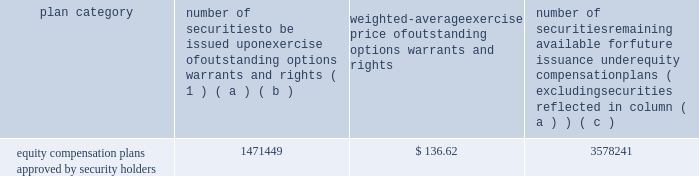Part a0iii item a010 .
Directors , executive officers and corporate governance for the information required by this item a010 with respect to our executive officers , see part a0i , item 1 .
Of this report .
For the other information required by this item a010 , see 201celection of directors , 201d 201cnominees for election to the board of directors , 201d 201ccorporate governance 201d and 201csection a016 ( a ) beneficial ownership reporting compliance , 201d in the proxy statement for our 2019 annual meeting , which information is incorporated herein by reference .
The proxy statement for our 2019 annual meeting will be filed within 120 a0days after the end of the fiscal year covered by this annual report on form 10-k .
Item a011 .
Executive compensation for the information required by this item a011 , see 201ccompensation discussion and analysis , 201d 201ccompensation committee report , 201d and 201cexecutive compensation 201d in the proxy statement for our 2019 annual meeting , which information is incorporated herein by reference .
Item a012 .
Security ownership of certain beneficial owners and management and related stockholder matters for the information required by this item a012 with respect to beneficial ownership of our common stock , see 201csecurity ownership of certain beneficial owners and management 201d in the proxy statement for our 2019 annual meeting , which information is incorporated herein by reference .
The table sets forth certain information as of december a031 , 2018 regarding our equity plans : plan category number of securities to be issued upon exercise of outstanding options , warrants and rights ( 1 ) weighted-average exercise price of outstanding options , warrants and rights number of securities remaining available for future issuance under equity compensation plans ( excluding securities reflected in column ( a ) ( b ) ( c ) equity compensation plans approved by security holders 1471449 $ 136.62 3578241 ( 1 ) the number of securities in column ( a ) include 22290 shares of common stock underlying performance stock units if maximum performance levels are achieved ; the actual number of shares , if any , to be issued with respect to the performance stock units will be based on performance with respect to specified financial and relative stock price measures .
Item a013 .
Certain relationships and related transactions , and director independence for the information required by this item a013 , see 201ccertain transactions 201d and 201ccorporate governance 201d in the proxy statement for our 2019 annual meeting , which information is incorporated herein by reference .
Item a014 .
Principal accounting fees and services for the information required by this item a014 , see 201caudit and non-audit fees 201d and 201caudit committee pre-approval procedures 201d in the proxy statement for our 2019 annual meeting , which information is incorporated herein by reference. .
Part a0iii item a010 .
Directors , executive officers and corporate governance for the information required by this item a010 with respect to our executive officers , see part a0i , item 1 .
Of this report .
For the other information required by this item a010 , see 201celection of directors , 201d 201cnominees for election to the board of directors , 201d 201ccorporate governance 201d and 201csection a016 ( a ) beneficial ownership reporting compliance , 201d in the proxy statement for our 2019 annual meeting , which information is incorporated herein by reference .
The proxy statement for our 2019 annual meeting will be filed within 120 a0days after the end of the fiscal year covered by this annual report on form 10-k .
Item a011 .
Executive compensation for the information required by this item a011 , see 201ccompensation discussion and analysis , 201d 201ccompensation committee report , 201d and 201cexecutive compensation 201d in the proxy statement for our 2019 annual meeting , which information is incorporated herein by reference .
Item a012 .
Security ownership of certain beneficial owners and management and related stockholder matters for the information required by this item a012 with respect to beneficial ownership of our common stock , see 201csecurity ownership of certain beneficial owners and management 201d in the proxy statement for our 2019 annual meeting , which information is incorporated herein by reference .
The following table sets forth certain information as of december a031 , 2018 regarding our equity plans : plan category number of securities to be issued upon exercise of outstanding options , warrants and rights ( 1 ) weighted-average exercise price of outstanding options , warrants and rights number of securities remaining available for future issuance under equity compensation plans ( excluding securities reflected in column ( a ) ( b ) ( c ) equity compensation plans approved by security holders 1471449 $ 136.62 3578241 ( 1 ) the number of securities in column ( a ) include 22290 shares of common stock underlying performance stock units if maximum performance levels are achieved ; the actual number of shares , if any , to be issued with respect to the performance stock units will be based on performance with respect to specified financial and relative stock price measures .
Item a013 .
Certain relationships and related transactions , and director independence for the information required by this item a013 , see 201ccertain transactions 201d and 201ccorporate governance 201d in the proxy statement for our 2019 annual meeting , which information is incorporated herein by reference .
Item a014 .
Principal accounting fees and services for the information required by this item a014 , see 201caudit and non-audit fees 201d and 201caudit committee pre-approval procedures 201d in the proxy statement for our 2019 annual meeting , which information is incorporated herein by reference. .
What portion of the securities approved by the security holders remains available for future issunce? 
Computations: (3578241 / (1471449 + 3578241))
Answer: 0.70861. 